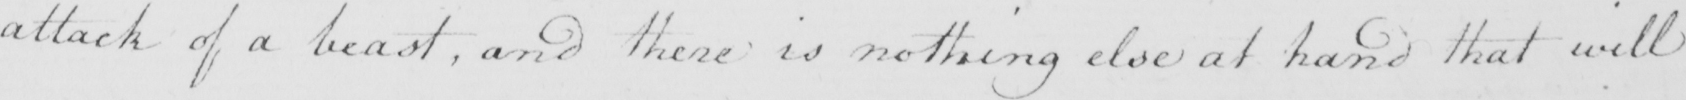Please provide the text content of this handwritten line. attack of a beast , and there is nothing else at hand that will 